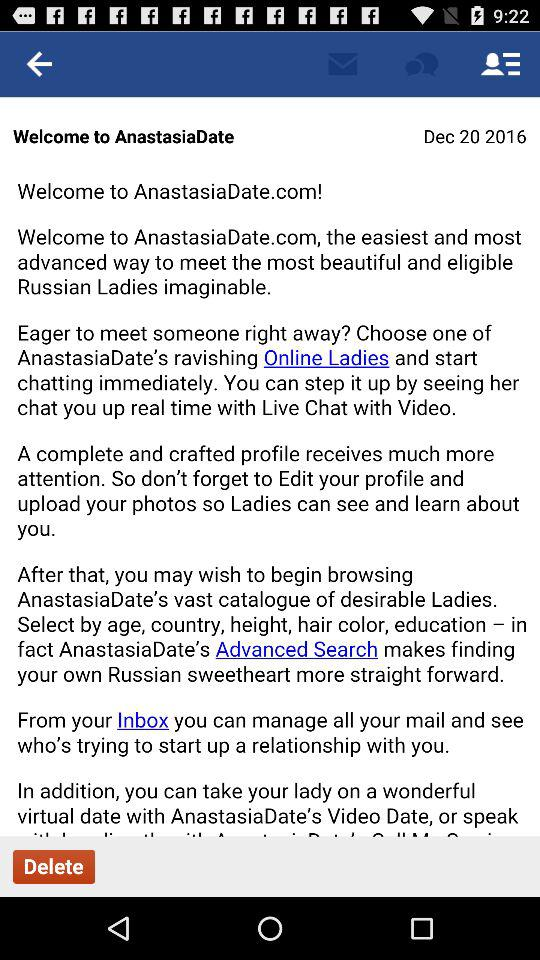What application is used to log in? The application "Facebook" is used to log in. 